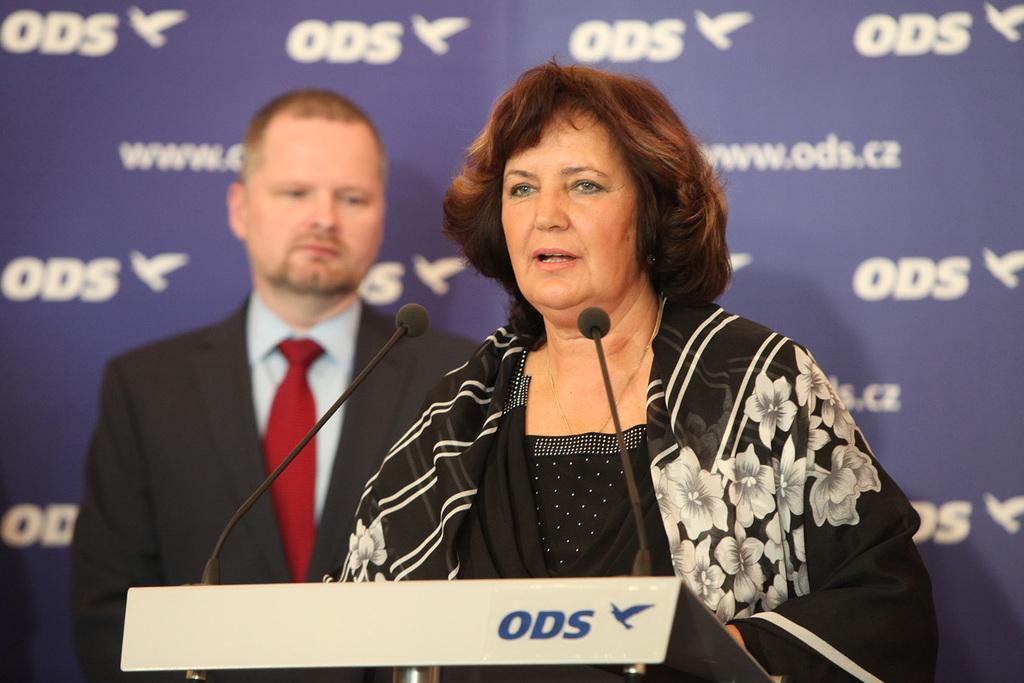Can you describe this image briefly? In this image I can see a man and a woman. Here I can see a podium and microphones. In the background I can see something written on a wall. 